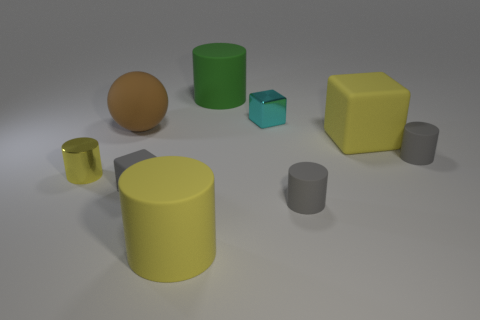The big matte object that is the same shape as the cyan shiny object is what color?
Offer a very short reply. Yellow. Is the number of small cyan metallic blocks that are behind the big green rubber cylinder greater than the number of small metal cylinders that are in front of the large yellow matte cube?
Your response must be concise. No. How many other things are there of the same shape as the green thing?
Offer a terse response. 4. Is there a brown rubber ball in front of the tiny metal thing that is in front of the small cyan cube?
Your response must be concise. No. How many cyan metal things are there?
Keep it short and to the point. 1. There is a small metal cube; is its color the same as the metal thing that is in front of the big brown matte sphere?
Your answer should be very brief. No. Are there more large green rubber things than rubber blocks?
Provide a succinct answer. No. Is there any other thing that has the same color as the small matte block?
Ensure brevity in your answer.  Yes. What number of other things are the same size as the shiny cylinder?
Give a very brief answer. 4. What material is the small block that is on the right side of the big cylinder behind the small matte cylinder that is behind the small metal cylinder made of?
Make the answer very short. Metal. 